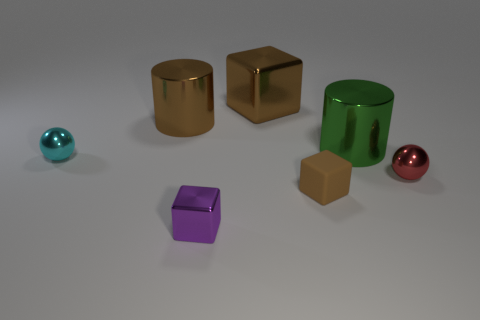How many small shiny blocks are in front of the shiny cube in front of the big brown block?
Make the answer very short. 0. There is a tiny block that is the same material as the small red thing; what color is it?
Offer a very short reply. Purple. Is there a red metallic object that has the same size as the brown rubber object?
Provide a short and direct response. Yes. What is the shape of the purple metallic thing that is the same size as the red object?
Your answer should be compact. Cube. Are there any other small cyan rubber things that have the same shape as the tiny rubber object?
Ensure brevity in your answer.  No. Does the large green cylinder have the same material as the big brown thing that is on the left side of the large metallic block?
Offer a very short reply. Yes. Are there any small rubber things of the same color as the rubber cube?
Give a very brief answer. No. What number of other things are there of the same material as the green thing
Provide a succinct answer. 5. There is a large metal block; is it the same color as the tiny metal object to the right of the small purple metallic block?
Make the answer very short. No. Is the number of red balls that are to the left of the green metal cylinder greater than the number of blue cubes?
Your answer should be compact. No. 